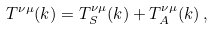Convert formula to latex. <formula><loc_0><loc_0><loc_500><loc_500>T ^ { \nu \mu } ( k ) = T _ { S } ^ { \nu \mu } ( k ) + T _ { A } ^ { \nu \mu } ( k ) \, ,</formula> 